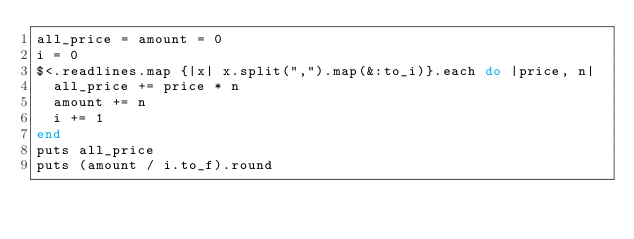<code> <loc_0><loc_0><loc_500><loc_500><_Ruby_>all_price = amount = 0
i = 0
$<.readlines.map {|x| x.split(",").map(&:to_i)}.each do |price, n|
  all_price += price * n
  amount += n
  i += 1
end
puts all_price
puts (amount / i.to_f).round
</code> 